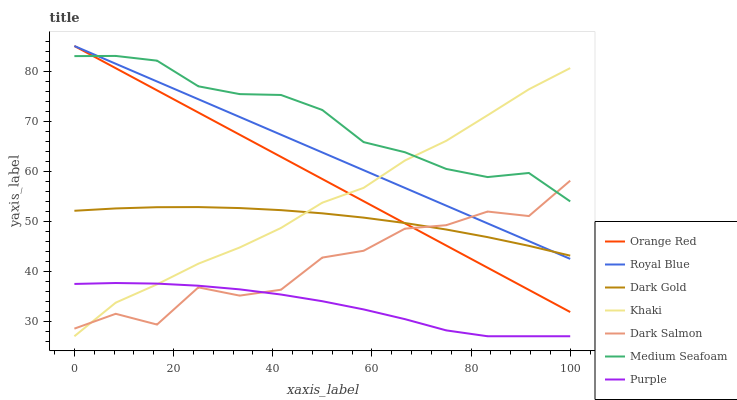Does Purple have the minimum area under the curve?
Answer yes or no. Yes. Does Medium Seafoam have the maximum area under the curve?
Answer yes or no. Yes. Does Dark Gold have the minimum area under the curve?
Answer yes or no. No. Does Dark Gold have the maximum area under the curve?
Answer yes or no. No. Is Orange Red the smoothest?
Answer yes or no. Yes. Is Dark Salmon the roughest?
Answer yes or no. Yes. Is Dark Gold the smoothest?
Answer yes or no. No. Is Dark Gold the roughest?
Answer yes or no. No. Does Khaki have the lowest value?
Answer yes or no. Yes. Does Dark Gold have the lowest value?
Answer yes or no. No. Does Royal Blue have the highest value?
Answer yes or no. Yes. Does Dark Gold have the highest value?
Answer yes or no. No. Is Purple less than Orange Red?
Answer yes or no. Yes. Is Medium Seafoam greater than Dark Gold?
Answer yes or no. Yes. Does Orange Red intersect Dark Gold?
Answer yes or no. Yes. Is Orange Red less than Dark Gold?
Answer yes or no. No. Is Orange Red greater than Dark Gold?
Answer yes or no. No. Does Purple intersect Orange Red?
Answer yes or no. No. 